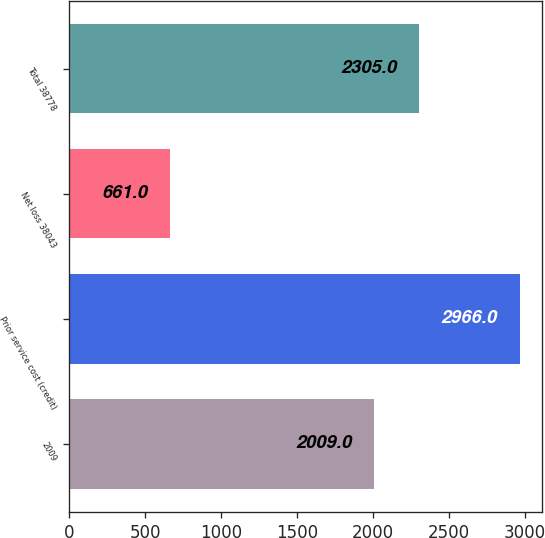Convert chart. <chart><loc_0><loc_0><loc_500><loc_500><bar_chart><fcel>2009<fcel>Prior service cost (credit)<fcel>Net loss 38043<fcel>Total 38778<nl><fcel>2009<fcel>2966<fcel>661<fcel>2305<nl></chart> 